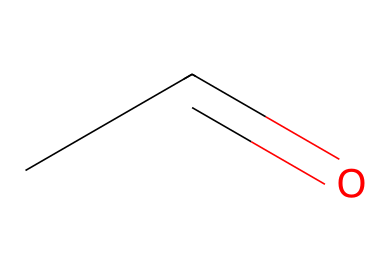What is the molecular formula of acetaldehyde? The molecular formula can be derived from the SMILES notation. Each letter represents an atom; 'C' stands for carbon and 'O' for oxygen. In the SMILES CC=O, there are two carbon atoms and one oxygen atom, giving us C2H4O. Therefore, the molecular formula is C2H4O.
Answer: C2H4O How many hydrogen atoms are present in acetaldehyde? From the SMILES CC=O, there are two carbon atoms indicated by 'CC', and typically each carbon can bond with up to four elements. In acetaldehyde, there are a total of four hydrogen atoms to balance the carbon and oxygen, specifically bonded to one carbon while the other is part of the double bond with oxygen. Thus, the number of hydrogen atoms is four.
Answer: four What is the significance of the carbonyl group in acetaldehyde? The carbonyl group is characterized by the 'C=O' bond present in the structure (CC=O). It plays a critical role in defining the properties of aldehydes, including their reactivity and ability to undergo further chemical transformations. Acetaldehyde, like other aldehydes, has the carbonyl group at the end of the carbon chain, making it reactive. The carbonyl group signifies that this compound is indeed an aldehyde.
Answer: carbonyl group What type of functional group is present in acetaldehyde? The functional group in acetaldehyde can be identified from the SMILES representation. The 'C=O' indicates the presence of a carbonyl group, which in this context (positioned with a hydrogen on one side) defines it as an aldehyde functional group. Therefore, the functional group in acetaldehyde is an aldehyde.
Answer: aldehyde How does acetaldehyde contribute to hangovers? Acetaldehyde is a byproduct of ethanol metabolism (as indicated by its connection to alcohol metabolism). It can be toxic and leads to a range of unpleasant physiological responses. This compound is known to cause many hangover symptoms due to its potentially harmful effects on the body, correlating directly with alcohol consumption. Therefore, acetaldehyde contributes to hangovers.
Answer: hangovers 